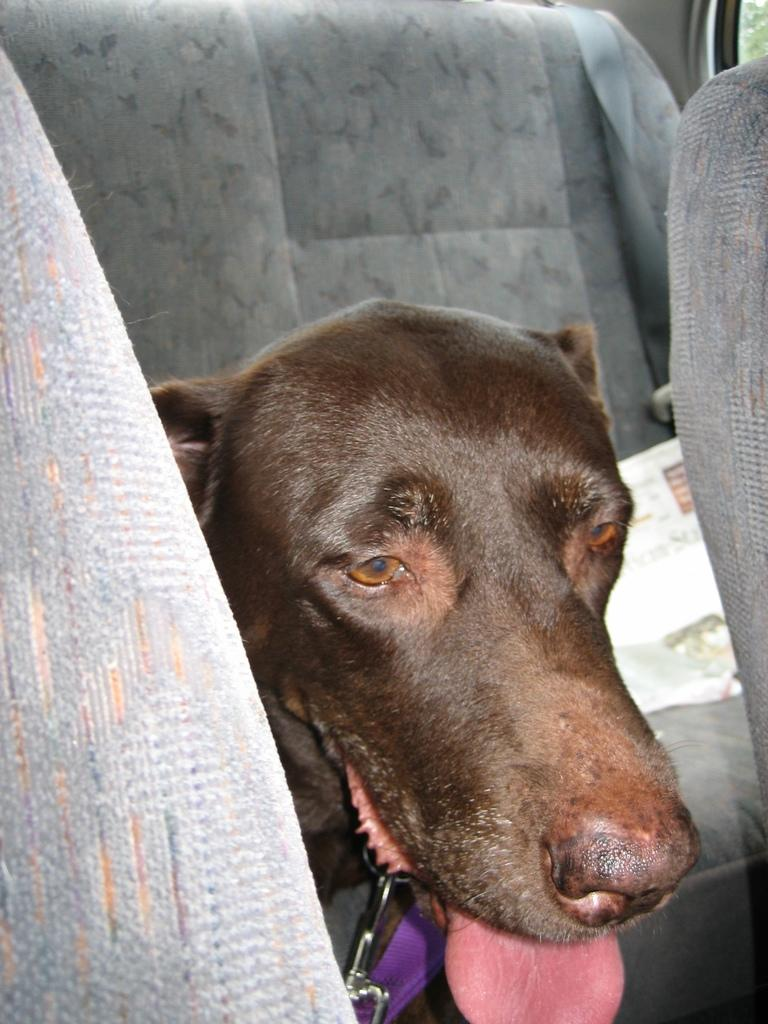What animal can be seen inside the car in the image? There is a dog sitting inside the car in the image. What is located beside the dog in the image? There is a newspaper beside the dog in the image. What type of window is visible on the right side of the image? There is a glass window on the right side of the image. What type of actor is sitting next to the dog in the image? There is no actor present in the image; it only features a dog sitting inside the car. What smell can be detected coming from the dog in the image? The image does not provide any information about smells, so it cannot be determined from the image. 